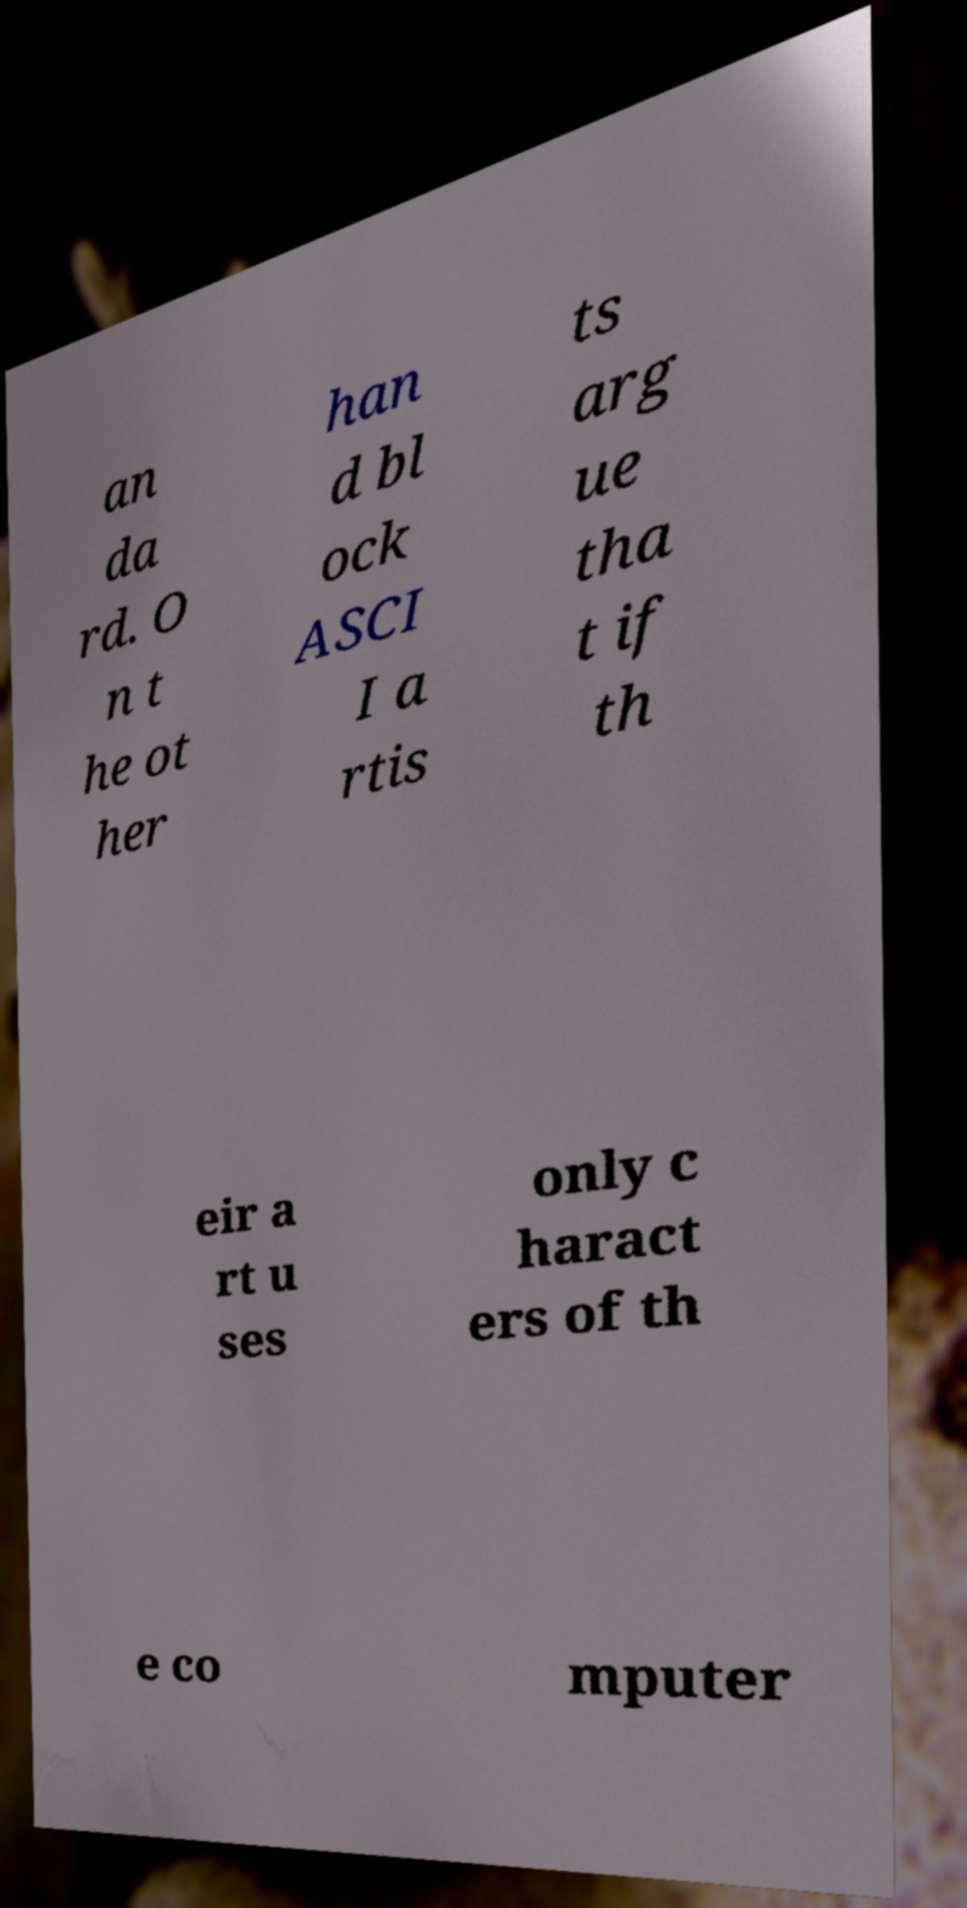Please identify and transcribe the text found in this image. an da rd. O n t he ot her han d bl ock ASCI I a rtis ts arg ue tha t if th eir a rt u ses only c haract ers of th e co mputer 